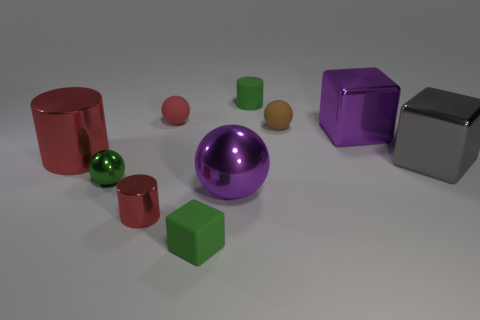How many red cylinders must be subtracted to get 1 red cylinders? 1 Subtract 1 balls. How many balls are left? 3 Subtract all cylinders. How many objects are left? 7 Add 7 green spheres. How many green spheres are left? 8 Add 7 small balls. How many small balls exist? 10 Subtract 0 red cubes. How many objects are left? 10 Subtract all big cyan matte blocks. Subtract all tiny things. How many objects are left? 4 